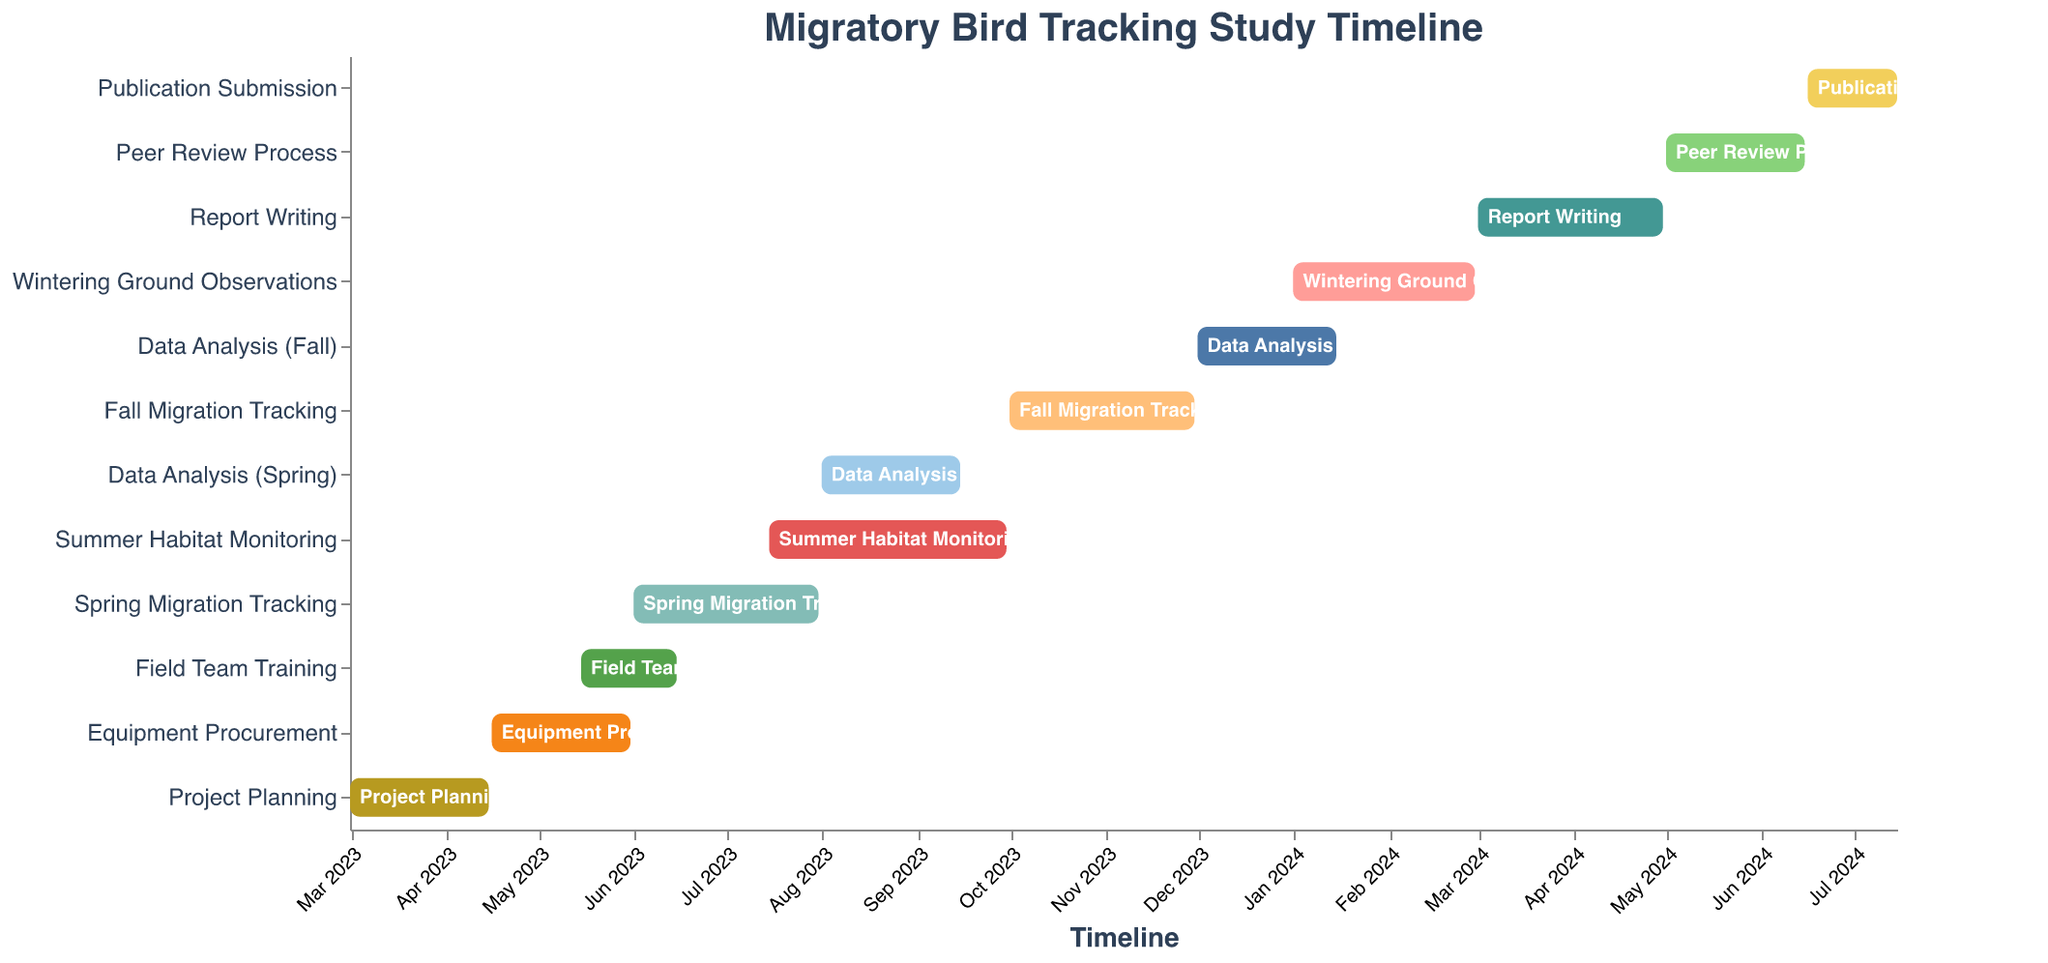What is the title of the Gantt chart? The title is displayed at the top of the chart.
Answer: Migratory Bird Tracking Study Timeline When does the "Field Team Training" task start and end? Locate "Field Team Training" on the Y-axis and refer to the X-axis for its "Start" and "End" dates.
Answer: Start: May 15, 2023 - End: June 15, 2023 Which task has the longest duration? Calculate the duration of each task by subtracting the start date from the end date and find the task with the maximum duration.
Answer: Summer Habitat Monitoring How many tasks are scheduled between June 2023 and December 2023? Count the tasks that overlap with any part of the period from June 2023 to December 2023.
Answer: Five tasks (Spring Migration Tracking, Data Analysis (Spring), Summer Habitat Monitoring, Fall Migration Tracking, Data Analysis (Fall)) Which tasks overlap with the "Spring Migration Tracking"? Identify the time range for "Spring Migration Tracking" and find other tasks whose time ranges intersect with this range.
Answer: Field Team Training, Summer Habitat Monitoring What is the duration of the "Report Writing" task? Calculate the difference between the start date and end date of the "Report Writing" task.
Answer: 2 months Compare the timing of "Peer Review Process" and "Publication Submission". Which starts first and by how many days? Identify the start dates of both tasks and subtract to find the difference. "Peer Review Process" starts on May 1, 2024, and "Publication Submission" starts on June 16, 2024. Calculate the difference in days.
Answer: Peer Review Process starts first by 46 days Are there any tasks that start before the "Project Planning" task ends? Compare the end date of "Project Planning" with the start dates of other tasks and identify any that start before April 15, 2023.
Answer: No What is the total duration from the start of the first task to the end of the last task? Find the start date of the first task and the end date of the last task, then calculate the duration between these dates.
Answer: 17.5 months 